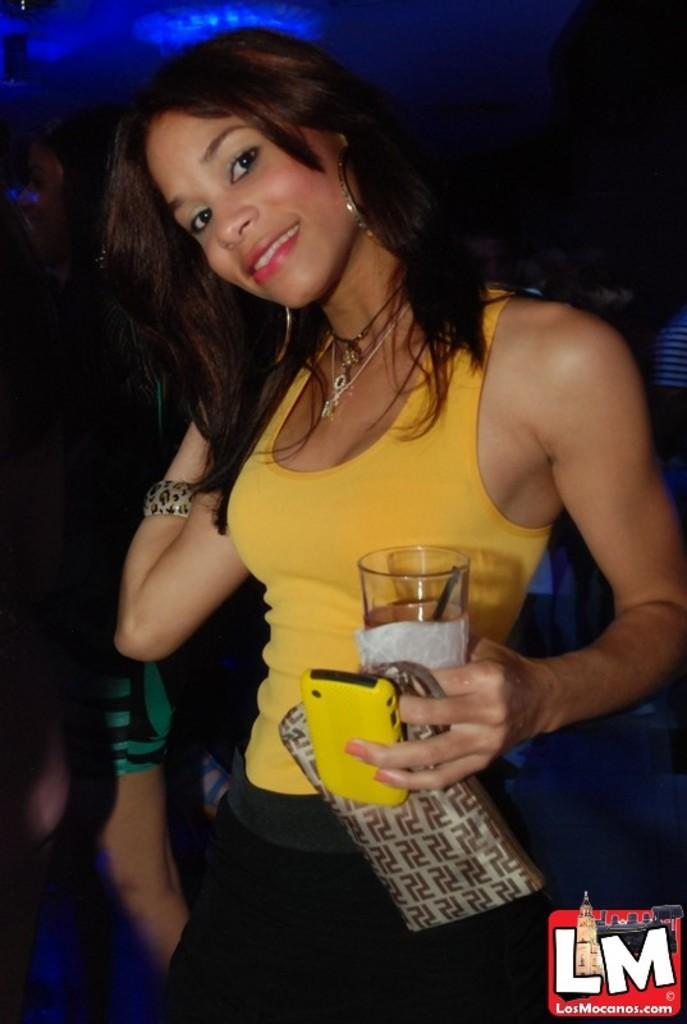What is the main subject of the image? The main subject of the image is a woman. What is the woman doing in the image? The woman is standing and posing for a photo. What objects is the woman holding in the image? The woman is holding a glass, a wallet, and a mobile. Are there any other people visible in the image? Yes, there are other people behind the woman in the image. What is the price of the wren in the jar in the image? There is no wren or jar present in the image. 